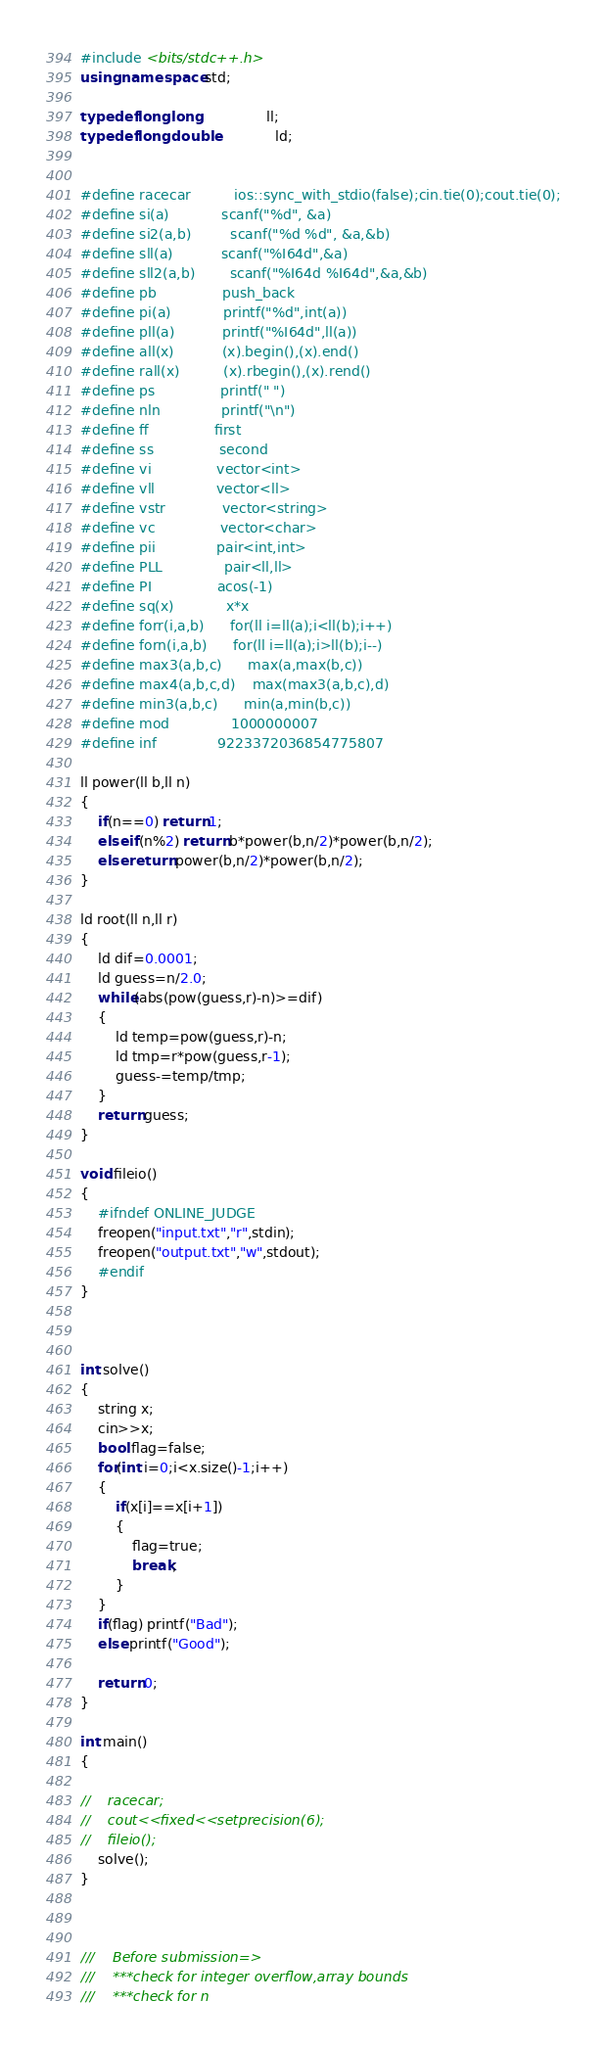Convert code to text. <code><loc_0><loc_0><loc_500><loc_500><_C++_>#include <bits/stdc++.h>
using namespace std;

typedef long long               ll;
typedef long double             ld;


#define racecar          ios::sync_with_stdio(false);cin.tie(0);cout.tie(0);
#define si(a)            scanf("%d", &a)
#define si2(a,b)         scanf("%d %d", &a,&b)
#define sll(a)           scanf("%I64d",&a)
#define sll2(a,b)        scanf("%I64d %I64d",&a,&b)
#define pb               push_back
#define pi(a)            printf("%d",int(a))
#define pll(a)           printf("%I64d",ll(a))
#define all(x)           (x).begin(),(x).end()
#define rall(x)          (x).rbegin(),(x).rend()
#define ps               printf(" ")
#define nln              printf("\n")
#define ff               first
#define ss               second
#define vi               vector<int>
#define vll              vector<ll>
#define vstr             vector<string>
#define vc               vector<char>
#define pii              pair<int,int>
#define PLL              pair<ll,ll>
#define PI               acos(-1)
#define sq(x)            x*x
#define forr(i,a,b)      for(ll i=ll(a);i<ll(b);i++)
#define forn(i,a,b)      for(ll i=ll(a);i>ll(b);i--)
#define max3(a,b,c)      max(a,max(b,c))
#define max4(a,b,c,d)    max(max3(a,b,c),d)
#define min3(a,b,c)      min(a,min(b,c))
#define mod              1000000007
#define inf              9223372036854775807

ll power(ll b,ll n)
{
    if(n==0) return 1;
    else if(n%2) return b*power(b,n/2)*power(b,n/2);
    else return power(b,n/2)*power(b,n/2);
} 

ld root(ll n,ll r)
{
    ld dif=0.0001;
    ld guess=n/2.0;
    while(abs(pow(guess,r)-n)>=dif)
    {
        ld temp=pow(guess,r)-n;
        ld tmp=r*pow(guess,r-1);
        guess-=temp/tmp;
    }
    return guess;
}

void fileio()
{
    #ifndef ONLINE_JUDGE
    freopen("input.txt","r",stdin);
    freopen("output.txt","w",stdout);
    #endif
}

      

int solve()
{
	string x;
	cin>>x;
	bool flag=false;
	for(int i=0;i<x.size()-1;i++)
	{
		if(x[i]==x[i+1])
		{
			flag=true;
			break;
		}
	}
	if(flag) printf("Bad");
	else printf("Good");
    
	return 0;
}

int main()
{   

//    racecar;
//    cout<<fixed<<setprecision(6);
//    fileio();
    solve();
}



///    Before submission=>
///    ***check for integer overflow,array bounds
///    ***check for n</code> 